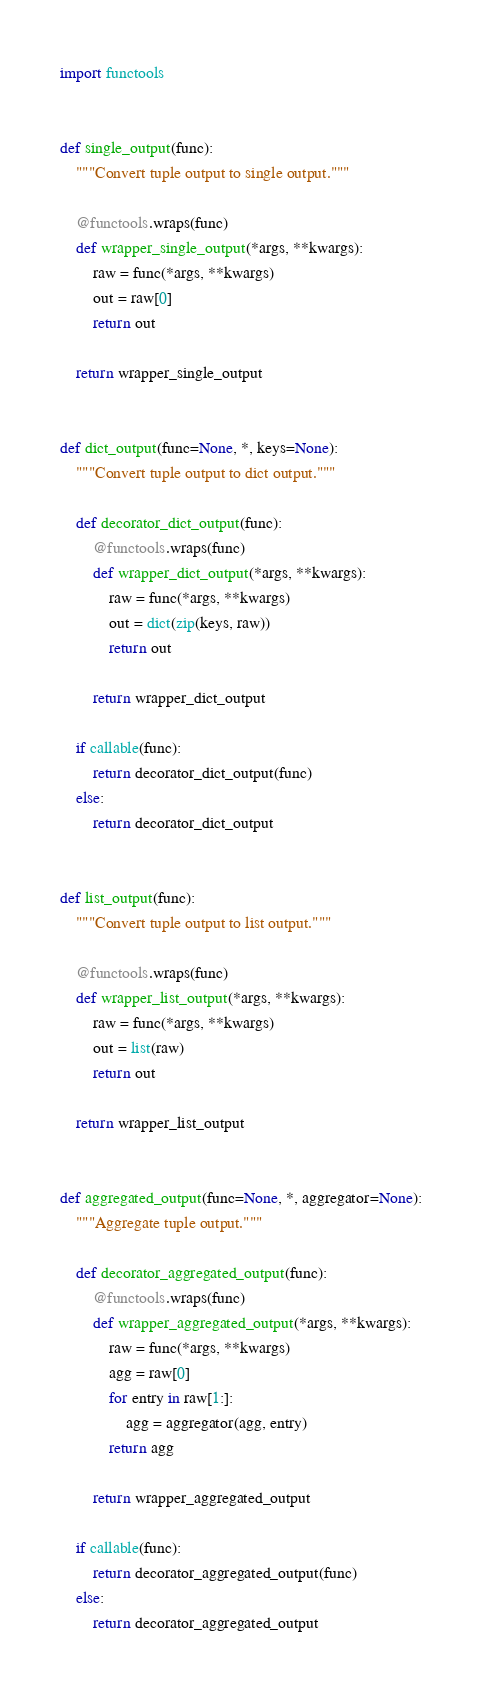<code> <loc_0><loc_0><loc_500><loc_500><_Python_>import functools


def single_output(func):
    """Convert tuple output to single output."""

    @functools.wraps(func)
    def wrapper_single_output(*args, **kwargs):
        raw = func(*args, **kwargs)
        out = raw[0]
        return out

    return wrapper_single_output


def dict_output(func=None, *, keys=None):
    """Convert tuple output to dict output."""

    def decorator_dict_output(func):
        @functools.wraps(func)
        def wrapper_dict_output(*args, **kwargs):
            raw = func(*args, **kwargs)
            out = dict(zip(keys, raw))
            return out

        return wrapper_dict_output

    if callable(func):
        return decorator_dict_output(func)
    else:
        return decorator_dict_output


def list_output(func):
    """Convert tuple output to list output."""

    @functools.wraps(func)
    def wrapper_list_output(*args, **kwargs):
        raw = func(*args, **kwargs)
        out = list(raw)
        return out

    return wrapper_list_output


def aggregated_output(func=None, *, aggregator=None):
    """Aggregate tuple output."""

    def decorator_aggregated_output(func):
        @functools.wraps(func)
        def wrapper_aggregated_output(*args, **kwargs):
            raw = func(*args, **kwargs)
            agg = raw[0]
            for entry in raw[1:]:
                agg = aggregator(agg, entry)
            return agg

        return wrapper_aggregated_output

    if callable(func):
        return decorator_aggregated_output(func)
    else:
        return decorator_aggregated_output
</code> 